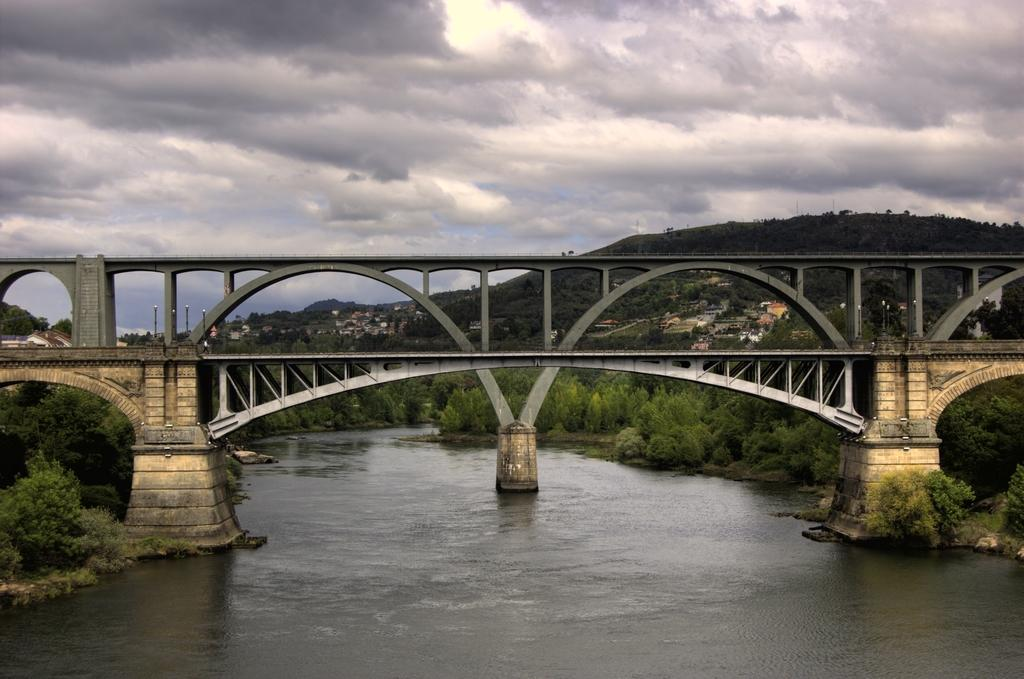What is the main feature of the landscape in the image? There is water in the image, along with a bridge, buildings, trees, and hills. Can you describe the bridge in the image? The bridge is a structure that spans the water in the image. What type of vegetation is present in the image? There are trees in the image. What is visible in the background of the image? The sky is visible in the background of the image. How many steps can be seen leading up to the bridge in the image? There are no steps visible in the image. 